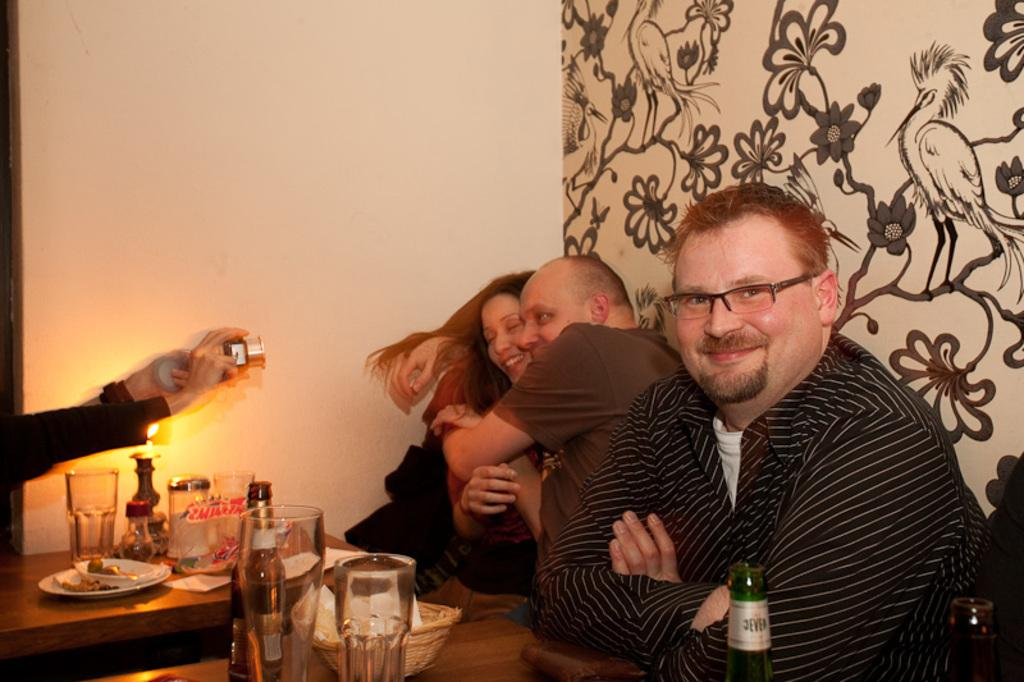What is happening in the image involving the people and the table? There are people sitting at a table in the image, which suggests they might be eating or socializing. What can be seen on the table besides the people? There are food items on the table, which supports the idea that they might be eating. What is happening in the background of the image? In the background, two people are posing for a picture, and a guy is clicking the picture. What might be the purpose of the guy clicking the picture? The guy might be capturing a memory or documenting the event. What type of lunchroom can be seen in the image? There is no lunchroom present in the image; it features people sitting at a table with food items. What is the learning environment like in the image? There is no learning environment present in the image; it features people sitting at a table with food items and others posing for a picture. 